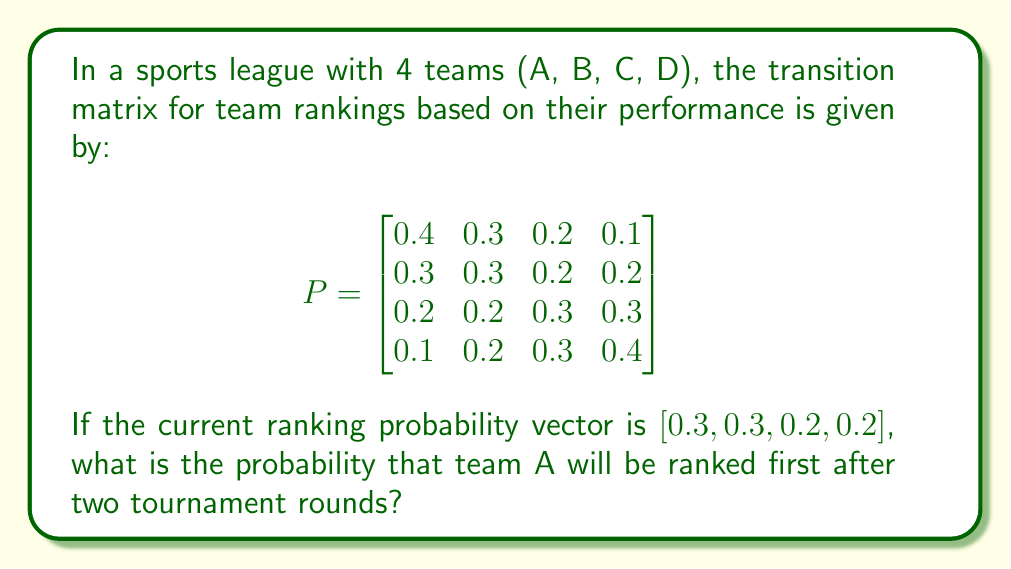Can you solve this math problem? To solve this problem, we'll use the properties of Markov chains:

1. The given transition matrix $P$ represents the probabilities of teams changing ranks in one round.

2. The current ranking probability vector is $v_0 = [0.3, 0.3, 0.2, 0.2]$.

3. To find the ranking probabilities after two rounds, we need to multiply the initial vector by the transition matrix twice:

   $v_2 = v_0 \cdot P^2$

4. First, let's calculate $P^2$:

   $$P^2 = P \cdot P = \begin{bmatrix}
   0.31 & 0.28 & 0.23 & 0.18 \\
   0.28 & 0.27 & 0.24 & 0.21 \\
   0.23 & 0.24 & 0.26 & 0.27 \\
   0.18 & 0.21 & 0.27 & 0.34
   \end{bmatrix}$$

5. Now, we multiply $v_0$ by $P^2$:

   $v_2 = [0.3, 0.3, 0.2, 0.2] \cdot \begin{bmatrix}
   0.31 & 0.28 & 0.23 & 0.18 \\
   0.28 & 0.27 & 0.24 & 0.21 \\
   0.23 & 0.24 & 0.26 & 0.27 \\
   0.18 & 0.21 & 0.27 & 0.34
   \end{bmatrix}$

6. Performing the matrix multiplication:

   $v_2 = [0.274, 0.262, 0.244, 0.22]$

7. The probability that team A will be ranked first after two tournament rounds is the first element of $v_2$, which is 0.274 or 27.4%.
Answer: 0.274 